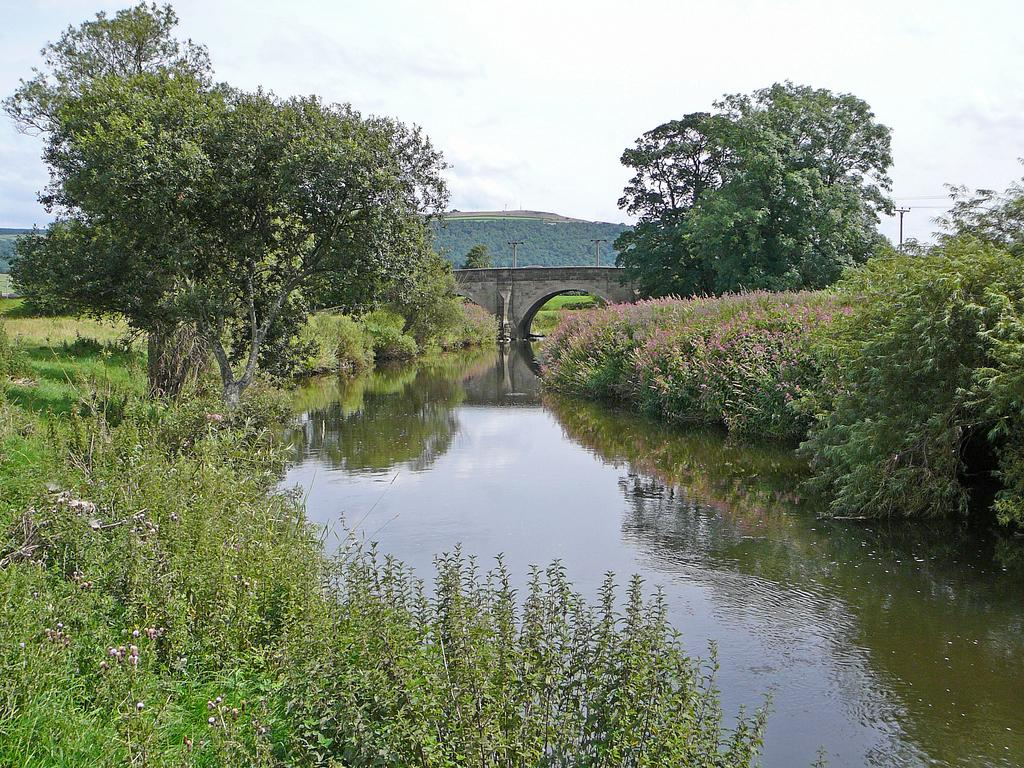What is the primary element present in the image? There is water in the image. What structure can be seen crossing over the water? There is a bridge in the image. What type of vegetation is visible in the image? There are plants, grass, and trees in the image. What are the poles used for in the image? The purpose of the poles in the image is not specified, but they could be for supporting structures or utilities. What can be seen in the background of the image? The sky is visible in the background of the image. What type of jelly can be seen floating on the water in the image? There is no jelly present in the image; it features water, a bridge, plants, grass, trees, poles, and the sky. How many feet are visible in the image? There are no feet visible in the image. 